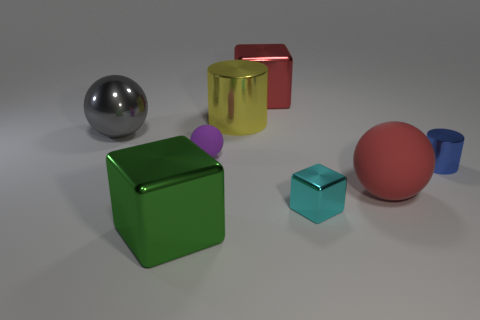There is a metal object that is the same color as the large matte object; what size is it?
Offer a terse response. Large. There is a big object that is in front of the tiny purple matte object and right of the large yellow cylinder; what is its color?
Ensure brevity in your answer.  Red. There is a large red thing that is made of the same material as the tiny purple thing; what is its shape?
Your answer should be very brief. Sphere. What number of metal things are both in front of the big yellow shiny thing and to the right of the yellow cylinder?
Provide a short and direct response. 2. Are there any matte spheres in front of the blue shiny cylinder?
Provide a succinct answer. Yes. There is a yellow metallic object behind the tiny purple rubber object; is its shape the same as the blue thing in front of the gray shiny object?
Provide a short and direct response. Yes. How many things are red balls or red things that are in front of the large gray metallic thing?
Keep it short and to the point. 1. What number of other things are the same shape as the tiny blue shiny thing?
Offer a very short reply. 1. Do the cylinder right of the cyan thing and the red sphere have the same material?
Provide a short and direct response. No. How many things are small blue cylinders or red matte spheres?
Provide a succinct answer. 2. 